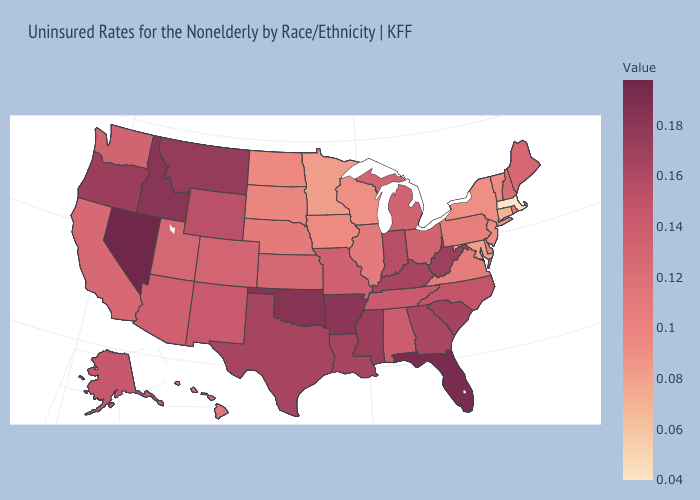Which states have the highest value in the USA?
Be succinct. Nevada. Does Pennsylvania have a higher value than West Virginia?
Answer briefly. No. Which states have the lowest value in the MidWest?
Concise answer only. Minnesota. Among the states that border Utah , does Colorado have the lowest value?
Answer briefly. Yes. Which states hav the highest value in the Northeast?
Keep it brief. Maine. Does New Mexico have a lower value than Illinois?
Quick response, please. No. 